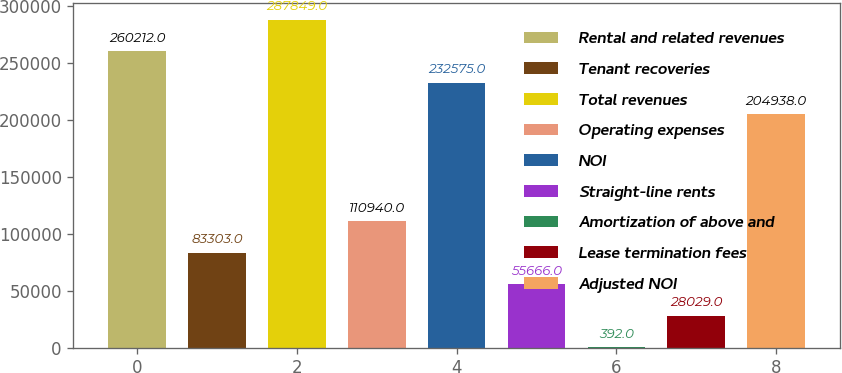Convert chart. <chart><loc_0><loc_0><loc_500><loc_500><bar_chart><fcel>Rental and related revenues<fcel>Tenant recoveries<fcel>Total revenues<fcel>Operating expenses<fcel>NOI<fcel>Straight-line rents<fcel>Amortization of above and<fcel>Lease termination fees<fcel>Adjusted NOI<nl><fcel>260212<fcel>83303<fcel>287849<fcel>110940<fcel>232575<fcel>55666<fcel>392<fcel>28029<fcel>204938<nl></chart> 